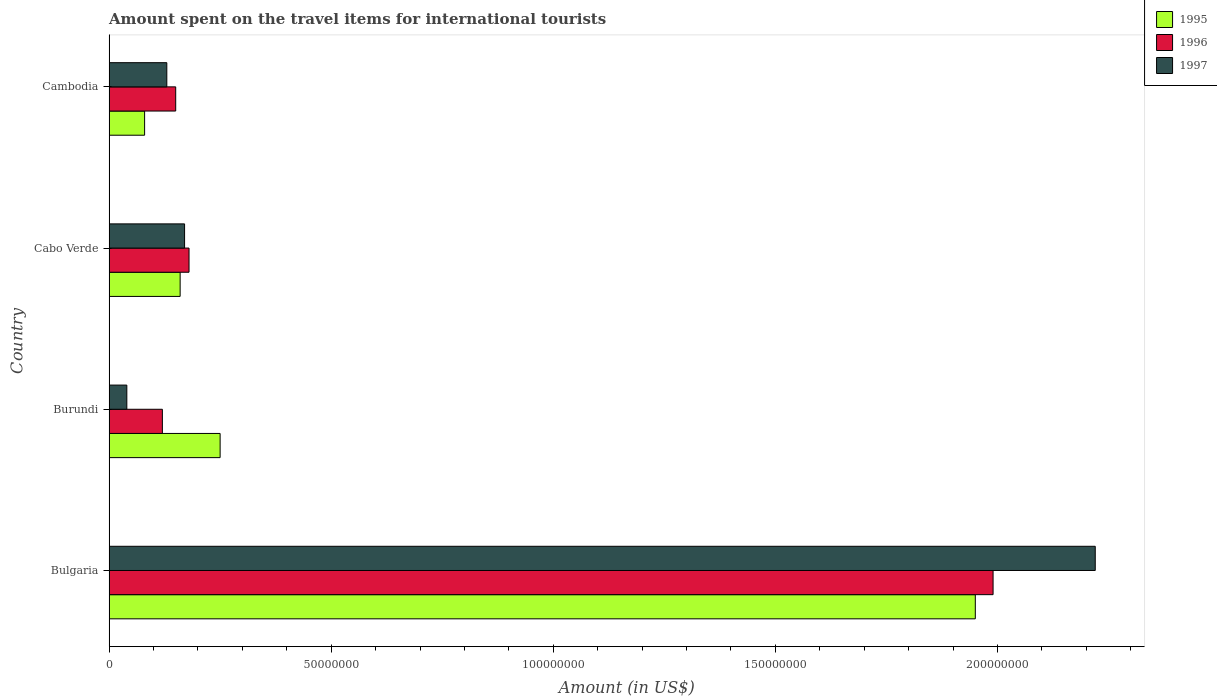How many different coloured bars are there?
Provide a succinct answer. 3. How many groups of bars are there?
Offer a terse response. 4. Are the number of bars per tick equal to the number of legend labels?
Your response must be concise. Yes. Are the number of bars on each tick of the Y-axis equal?
Keep it short and to the point. Yes. How many bars are there on the 3rd tick from the top?
Provide a succinct answer. 3. How many bars are there on the 1st tick from the bottom?
Provide a succinct answer. 3. What is the label of the 2nd group of bars from the top?
Provide a succinct answer. Cabo Verde. In how many cases, is the number of bars for a given country not equal to the number of legend labels?
Provide a succinct answer. 0. What is the amount spent on the travel items for international tourists in 1997 in Cabo Verde?
Your answer should be compact. 1.70e+07. Across all countries, what is the maximum amount spent on the travel items for international tourists in 1995?
Your answer should be very brief. 1.95e+08. In which country was the amount spent on the travel items for international tourists in 1997 maximum?
Provide a succinct answer. Bulgaria. In which country was the amount spent on the travel items for international tourists in 1995 minimum?
Your response must be concise. Cambodia. What is the total amount spent on the travel items for international tourists in 1995 in the graph?
Your answer should be very brief. 2.44e+08. What is the difference between the amount spent on the travel items for international tourists in 1997 in Bulgaria and that in Cambodia?
Your response must be concise. 2.09e+08. What is the difference between the amount spent on the travel items for international tourists in 1997 in Cambodia and the amount spent on the travel items for international tourists in 1995 in Bulgaria?
Offer a terse response. -1.82e+08. What is the average amount spent on the travel items for international tourists in 1997 per country?
Ensure brevity in your answer.  6.40e+07. What is the difference between the amount spent on the travel items for international tourists in 1997 and amount spent on the travel items for international tourists in 1996 in Bulgaria?
Keep it short and to the point. 2.30e+07. Is the amount spent on the travel items for international tourists in 1996 in Burundi less than that in Cabo Verde?
Keep it short and to the point. Yes. What is the difference between the highest and the second highest amount spent on the travel items for international tourists in 1997?
Make the answer very short. 2.05e+08. What is the difference between the highest and the lowest amount spent on the travel items for international tourists in 1997?
Offer a very short reply. 2.18e+08. In how many countries, is the amount spent on the travel items for international tourists in 1996 greater than the average amount spent on the travel items for international tourists in 1996 taken over all countries?
Your answer should be compact. 1. What does the 1st bar from the bottom in Bulgaria represents?
Offer a terse response. 1995. Is it the case that in every country, the sum of the amount spent on the travel items for international tourists in 1996 and amount spent on the travel items for international tourists in 1997 is greater than the amount spent on the travel items for international tourists in 1995?
Your response must be concise. No. How many bars are there?
Make the answer very short. 12. Are all the bars in the graph horizontal?
Provide a short and direct response. Yes. How many countries are there in the graph?
Make the answer very short. 4. Where does the legend appear in the graph?
Offer a very short reply. Top right. How many legend labels are there?
Keep it short and to the point. 3. How are the legend labels stacked?
Ensure brevity in your answer.  Vertical. What is the title of the graph?
Offer a very short reply. Amount spent on the travel items for international tourists. What is the label or title of the X-axis?
Ensure brevity in your answer.  Amount (in US$). What is the label or title of the Y-axis?
Offer a terse response. Country. What is the Amount (in US$) in 1995 in Bulgaria?
Your answer should be compact. 1.95e+08. What is the Amount (in US$) of 1996 in Bulgaria?
Your answer should be compact. 1.99e+08. What is the Amount (in US$) in 1997 in Bulgaria?
Provide a short and direct response. 2.22e+08. What is the Amount (in US$) in 1995 in Burundi?
Your answer should be compact. 2.50e+07. What is the Amount (in US$) of 1996 in Burundi?
Offer a terse response. 1.20e+07. What is the Amount (in US$) of 1995 in Cabo Verde?
Keep it short and to the point. 1.60e+07. What is the Amount (in US$) of 1996 in Cabo Verde?
Make the answer very short. 1.80e+07. What is the Amount (in US$) of 1997 in Cabo Verde?
Offer a very short reply. 1.70e+07. What is the Amount (in US$) in 1995 in Cambodia?
Ensure brevity in your answer.  8.00e+06. What is the Amount (in US$) of 1996 in Cambodia?
Ensure brevity in your answer.  1.50e+07. What is the Amount (in US$) in 1997 in Cambodia?
Your response must be concise. 1.30e+07. Across all countries, what is the maximum Amount (in US$) in 1995?
Your answer should be very brief. 1.95e+08. Across all countries, what is the maximum Amount (in US$) in 1996?
Your answer should be compact. 1.99e+08. Across all countries, what is the maximum Amount (in US$) in 1997?
Keep it short and to the point. 2.22e+08. Across all countries, what is the minimum Amount (in US$) of 1996?
Provide a short and direct response. 1.20e+07. Across all countries, what is the minimum Amount (in US$) of 1997?
Ensure brevity in your answer.  4.00e+06. What is the total Amount (in US$) in 1995 in the graph?
Offer a very short reply. 2.44e+08. What is the total Amount (in US$) of 1996 in the graph?
Provide a succinct answer. 2.44e+08. What is the total Amount (in US$) of 1997 in the graph?
Provide a short and direct response. 2.56e+08. What is the difference between the Amount (in US$) in 1995 in Bulgaria and that in Burundi?
Provide a succinct answer. 1.70e+08. What is the difference between the Amount (in US$) in 1996 in Bulgaria and that in Burundi?
Ensure brevity in your answer.  1.87e+08. What is the difference between the Amount (in US$) in 1997 in Bulgaria and that in Burundi?
Give a very brief answer. 2.18e+08. What is the difference between the Amount (in US$) of 1995 in Bulgaria and that in Cabo Verde?
Provide a succinct answer. 1.79e+08. What is the difference between the Amount (in US$) of 1996 in Bulgaria and that in Cabo Verde?
Make the answer very short. 1.81e+08. What is the difference between the Amount (in US$) of 1997 in Bulgaria and that in Cabo Verde?
Provide a short and direct response. 2.05e+08. What is the difference between the Amount (in US$) of 1995 in Bulgaria and that in Cambodia?
Offer a very short reply. 1.87e+08. What is the difference between the Amount (in US$) of 1996 in Bulgaria and that in Cambodia?
Offer a very short reply. 1.84e+08. What is the difference between the Amount (in US$) of 1997 in Bulgaria and that in Cambodia?
Offer a terse response. 2.09e+08. What is the difference between the Amount (in US$) of 1995 in Burundi and that in Cabo Verde?
Give a very brief answer. 9.00e+06. What is the difference between the Amount (in US$) in 1996 in Burundi and that in Cabo Verde?
Your response must be concise. -6.00e+06. What is the difference between the Amount (in US$) in 1997 in Burundi and that in Cabo Verde?
Ensure brevity in your answer.  -1.30e+07. What is the difference between the Amount (in US$) in 1995 in Burundi and that in Cambodia?
Keep it short and to the point. 1.70e+07. What is the difference between the Amount (in US$) of 1996 in Burundi and that in Cambodia?
Keep it short and to the point. -3.00e+06. What is the difference between the Amount (in US$) of 1997 in Burundi and that in Cambodia?
Give a very brief answer. -9.00e+06. What is the difference between the Amount (in US$) of 1995 in Cabo Verde and that in Cambodia?
Provide a succinct answer. 8.00e+06. What is the difference between the Amount (in US$) of 1996 in Cabo Verde and that in Cambodia?
Offer a terse response. 3.00e+06. What is the difference between the Amount (in US$) of 1997 in Cabo Verde and that in Cambodia?
Provide a short and direct response. 4.00e+06. What is the difference between the Amount (in US$) of 1995 in Bulgaria and the Amount (in US$) of 1996 in Burundi?
Provide a succinct answer. 1.83e+08. What is the difference between the Amount (in US$) in 1995 in Bulgaria and the Amount (in US$) in 1997 in Burundi?
Keep it short and to the point. 1.91e+08. What is the difference between the Amount (in US$) of 1996 in Bulgaria and the Amount (in US$) of 1997 in Burundi?
Offer a very short reply. 1.95e+08. What is the difference between the Amount (in US$) of 1995 in Bulgaria and the Amount (in US$) of 1996 in Cabo Verde?
Offer a terse response. 1.77e+08. What is the difference between the Amount (in US$) of 1995 in Bulgaria and the Amount (in US$) of 1997 in Cabo Verde?
Offer a very short reply. 1.78e+08. What is the difference between the Amount (in US$) in 1996 in Bulgaria and the Amount (in US$) in 1997 in Cabo Verde?
Your answer should be very brief. 1.82e+08. What is the difference between the Amount (in US$) of 1995 in Bulgaria and the Amount (in US$) of 1996 in Cambodia?
Your answer should be very brief. 1.80e+08. What is the difference between the Amount (in US$) of 1995 in Bulgaria and the Amount (in US$) of 1997 in Cambodia?
Make the answer very short. 1.82e+08. What is the difference between the Amount (in US$) of 1996 in Bulgaria and the Amount (in US$) of 1997 in Cambodia?
Provide a short and direct response. 1.86e+08. What is the difference between the Amount (in US$) of 1995 in Burundi and the Amount (in US$) of 1997 in Cabo Verde?
Ensure brevity in your answer.  8.00e+06. What is the difference between the Amount (in US$) of 1996 in Burundi and the Amount (in US$) of 1997 in Cabo Verde?
Keep it short and to the point. -5.00e+06. What is the average Amount (in US$) in 1995 per country?
Ensure brevity in your answer.  6.10e+07. What is the average Amount (in US$) in 1996 per country?
Your response must be concise. 6.10e+07. What is the average Amount (in US$) of 1997 per country?
Offer a terse response. 6.40e+07. What is the difference between the Amount (in US$) in 1995 and Amount (in US$) in 1997 in Bulgaria?
Give a very brief answer. -2.70e+07. What is the difference between the Amount (in US$) of 1996 and Amount (in US$) of 1997 in Bulgaria?
Ensure brevity in your answer.  -2.30e+07. What is the difference between the Amount (in US$) in 1995 and Amount (in US$) in 1996 in Burundi?
Keep it short and to the point. 1.30e+07. What is the difference between the Amount (in US$) in 1995 and Amount (in US$) in 1997 in Burundi?
Your response must be concise. 2.10e+07. What is the difference between the Amount (in US$) of 1996 and Amount (in US$) of 1997 in Burundi?
Give a very brief answer. 8.00e+06. What is the difference between the Amount (in US$) of 1995 and Amount (in US$) of 1996 in Cabo Verde?
Provide a succinct answer. -2.00e+06. What is the difference between the Amount (in US$) of 1996 and Amount (in US$) of 1997 in Cabo Verde?
Make the answer very short. 1.00e+06. What is the difference between the Amount (in US$) of 1995 and Amount (in US$) of 1996 in Cambodia?
Provide a short and direct response. -7.00e+06. What is the difference between the Amount (in US$) of 1995 and Amount (in US$) of 1997 in Cambodia?
Make the answer very short. -5.00e+06. What is the ratio of the Amount (in US$) in 1995 in Bulgaria to that in Burundi?
Your answer should be compact. 7.8. What is the ratio of the Amount (in US$) of 1996 in Bulgaria to that in Burundi?
Offer a very short reply. 16.58. What is the ratio of the Amount (in US$) of 1997 in Bulgaria to that in Burundi?
Give a very brief answer. 55.5. What is the ratio of the Amount (in US$) in 1995 in Bulgaria to that in Cabo Verde?
Keep it short and to the point. 12.19. What is the ratio of the Amount (in US$) in 1996 in Bulgaria to that in Cabo Verde?
Keep it short and to the point. 11.06. What is the ratio of the Amount (in US$) of 1997 in Bulgaria to that in Cabo Verde?
Give a very brief answer. 13.06. What is the ratio of the Amount (in US$) in 1995 in Bulgaria to that in Cambodia?
Offer a terse response. 24.38. What is the ratio of the Amount (in US$) of 1996 in Bulgaria to that in Cambodia?
Give a very brief answer. 13.27. What is the ratio of the Amount (in US$) of 1997 in Bulgaria to that in Cambodia?
Provide a succinct answer. 17.08. What is the ratio of the Amount (in US$) in 1995 in Burundi to that in Cabo Verde?
Offer a terse response. 1.56. What is the ratio of the Amount (in US$) in 1997 in Burundi to that in Cabo Verde?
Give a very brief answer. 0.24. What is the ratio of the Amount (in US$) in 1995 in Burundi to that in Cambodia?
Give a very brief answer. 3.12. What is the ratio of the Amount (in US$) of 1997 in Burundi to that in Cambodia?
Your answer should be compact. 0.31. What is the ratio of the Amount (in US$) in 1996 in Cabo Verde to that in Cambodia?
Ensure brevity in your answer.  1.2. What is the ratio of the Amount (in US$) of 1997 in Cabo Verde to that in Cambodia?
Give a very brief answer. 1.31. What is the difference between the highest and the second highest Amount (in US$) in 1995?
Provide a short and direct response. 1.70e+08. What is the difference between the highest and the second highest Amount (in US$) in 1996?
Your response must be concise. 1.81e+08. What is the difference between the highest and the second highest Amount (in US$) in 1997?
Offer a very short reply. 2.05e+08. What is the difference between the highest and the lowest Amount (in US$) of 1995?
Offer a very short reply. 1.87e+08. What is the difference between the highest and the lowest Amount (in US$) of 1996?
Offer a very short reply. 1.87e+08. What is the difference between the highest and the lowest Amount (in US$) of 1997?
Offer a terse response. 2.18e+08. 